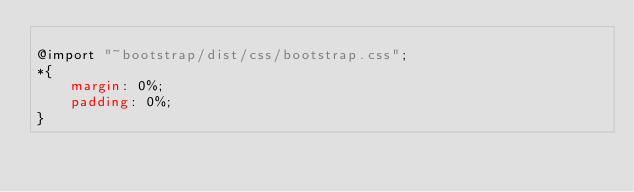<code> <loc_0><loc_0><loc_500><loc_500><_CSS_>
@import "~bootstrap/dist/css/bootstrap.css";
*{
    margin: 0%;
    padding: 0%;
}
</code> 